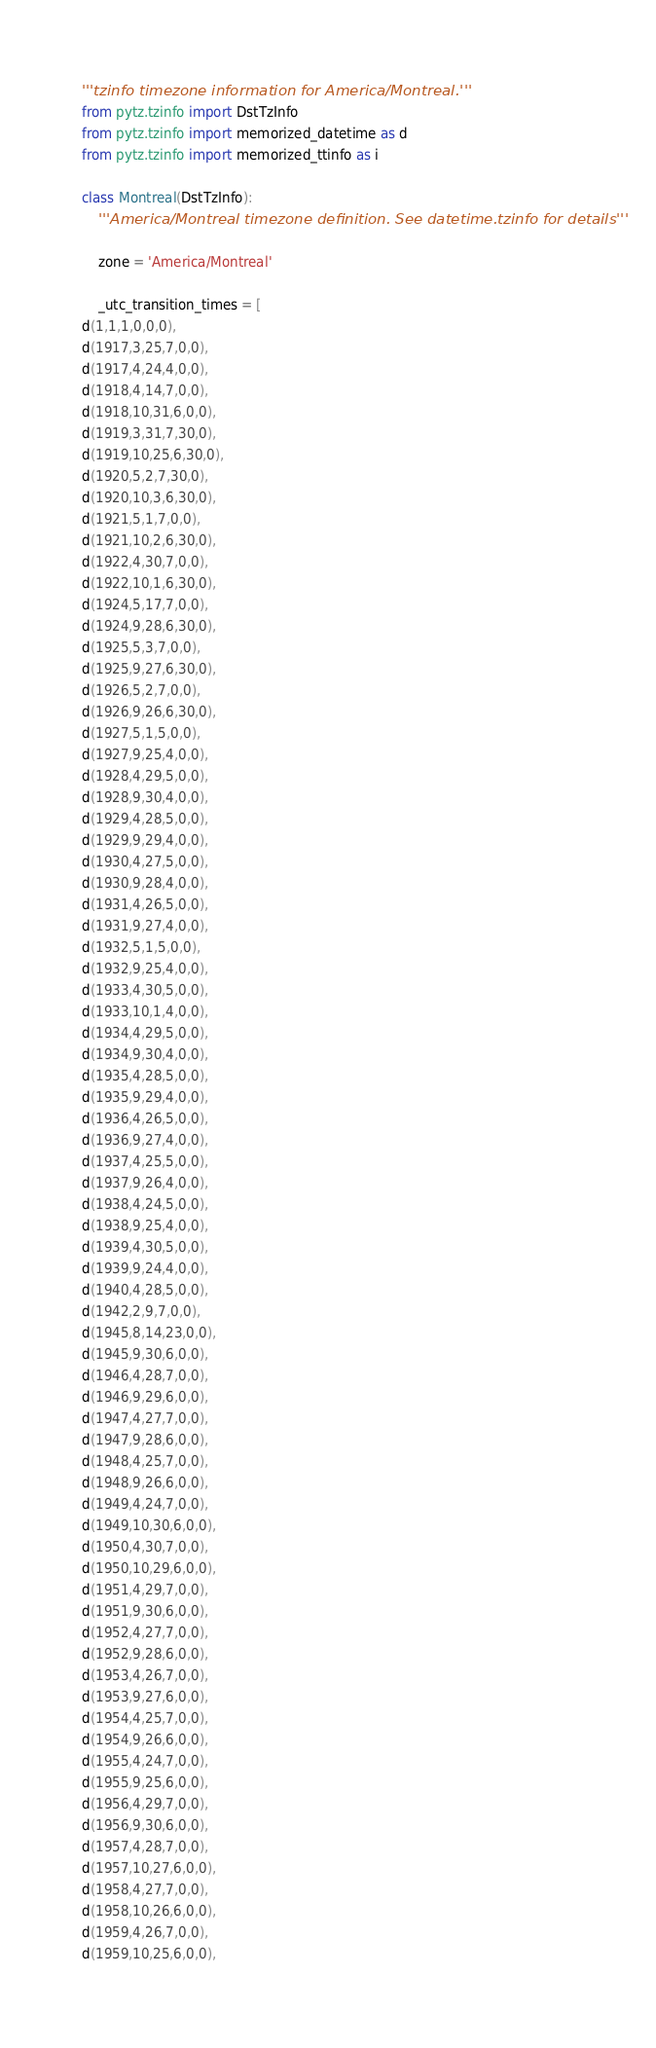Convert code to text. <code><loc_0><loc_0><loc_500><loc_500><_Python_>'''tzinfo timezone information for America/Montreal.'''
from pytz.tzinfo import DstTzInfo
from pytz.tzinfo import memorized_datetime as d
from pytz.tzinfo import memorized_ttinfo as i

class Montreal(DstTzInfo):
    '''America/Montreal timezone definition. See datetime.tzinfo for details'''

    zone = 'America/Montreal'

    _utc_transition_times = [
d(1,1,1,0,0,0),
d(1917,3,25,7,0,0),
d(1917,4,24,4,0,0),
d(1918,4,14,7,0,0),
d(1918,10,31,6,0,0),
d(1919,3,31,7,30,0),
d(1919,10,25,6,30,0),
d(1920,5,2,7,30,0),
d(1920,10,3,6,30,0),
d(1921,5,1,7,0,0),
d(1921,10,2,6,30,0),
d(1922,4,30,7,0,0),
d(1922,10,1,6,30,0),
d(1924,5,17,7,0,0),
d(1924,9,28,6,30,0),
d(1925,5,3,7,0,0),
d(1925,9,27,6,30,0),
d(1926,5,2,7,0,0),
d(1926,9,26,6,30,0),
d(1927,5,1,5,0,0),
d(1927,9,25,4,0,0),
d(1928,4,29,5,0,0),
d(1928,9,30,4,0,0),
d(1929,4,28,5,0,0),
d(1929,9,29,4,0,0),
d(1930,4,27,5,0,0),
d(1930,9,28,4,0,0),
d(1931,4,26,5,0,0),
d(1931,9,27,4,0,0),
d(1932,5,1,5,0,0),
d(1932,9,25,4,0,0),
d(1933,4,30,5,0,0),
d(1933,10,1,4,0,0),
d(1934,4,29,5,0,0),
d(1934,9,30,4,0,0),
d(1935,4,28,5,0,0),
d(1935,9,29,4,0,0),
d(1936,4,26,5,0,0),
d(1936,9,27,4,0,0),
d(1937,4,25,5,0,0),
d(1937,9,26,4,0,0),
d(1938,4,24,5,0,0),
d(1938,9,25,4,0,0),
d(1939,4,30,5,0,0),
d(1939,9,24,4,0,0),
d(1940,4,28,5,0,0),
d(1942,2,9,7,0,0),
d(1945,8,14,23,0,0),
d(1945,9,30,6,0,0),
d(1946,4,28,7,0,0),
d(1946,9,29,6,0,0),
d(1947,4,27,7,0,0),
d(1947,9,28,6,0,0),
d(1948,4,25,7,0,0),
d(1948,9,26,6,0,0),
d(1949,4,24,7,0,0),
d(1949,10,30,6,0,0),
d(1950,4,30,7,0,0),
d(1950,10,29,6,0,0),
d(1951,4,29,7,0,0),
d(1951,9,30,6,0,0),
d(1952,4,27,7,0,0),
d(1952,9,28,6,0,0),
d(1953,4,26,7,0,0),
d(1953,9,27,6,0,0),
d(1954,4,25,7,0,0),
d(1954,9,26,6,0,0),
d(1955,4,24,7,0,0),
d(1955,9,25,6,0,0),
d(1956,4,29,7,0,0),
d(1956,9,30,6,0,0),
d(1957,4,28,7,0,0),
d(1957,10,27,6,0,0),
d(1958,4,27,7,0,0),
d(1958,10,26,6,0,0),
d(1959,4,26,7,0,0),
d(1959,10,25,6,0,0),</code> 